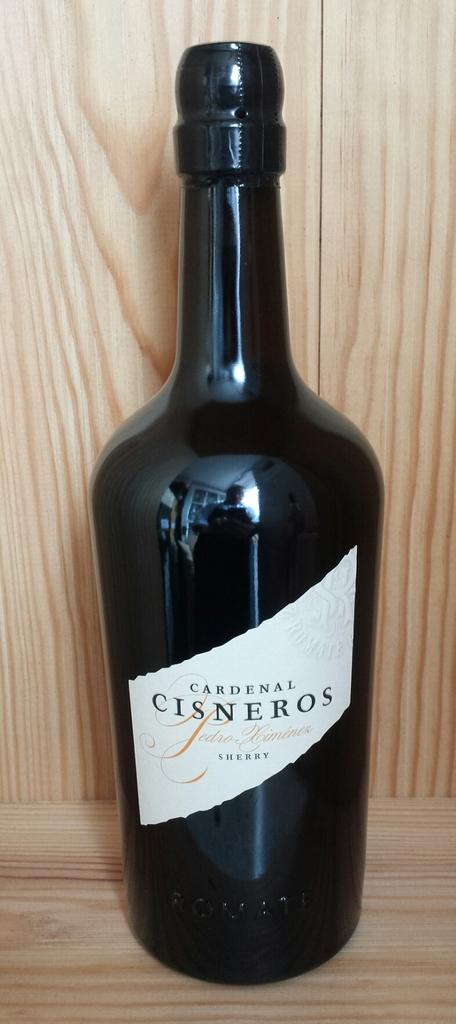<image>
Present a compact description of the photo's key features. Full, unopened, shapely bottle of Cardenal Cisneros sherry. 